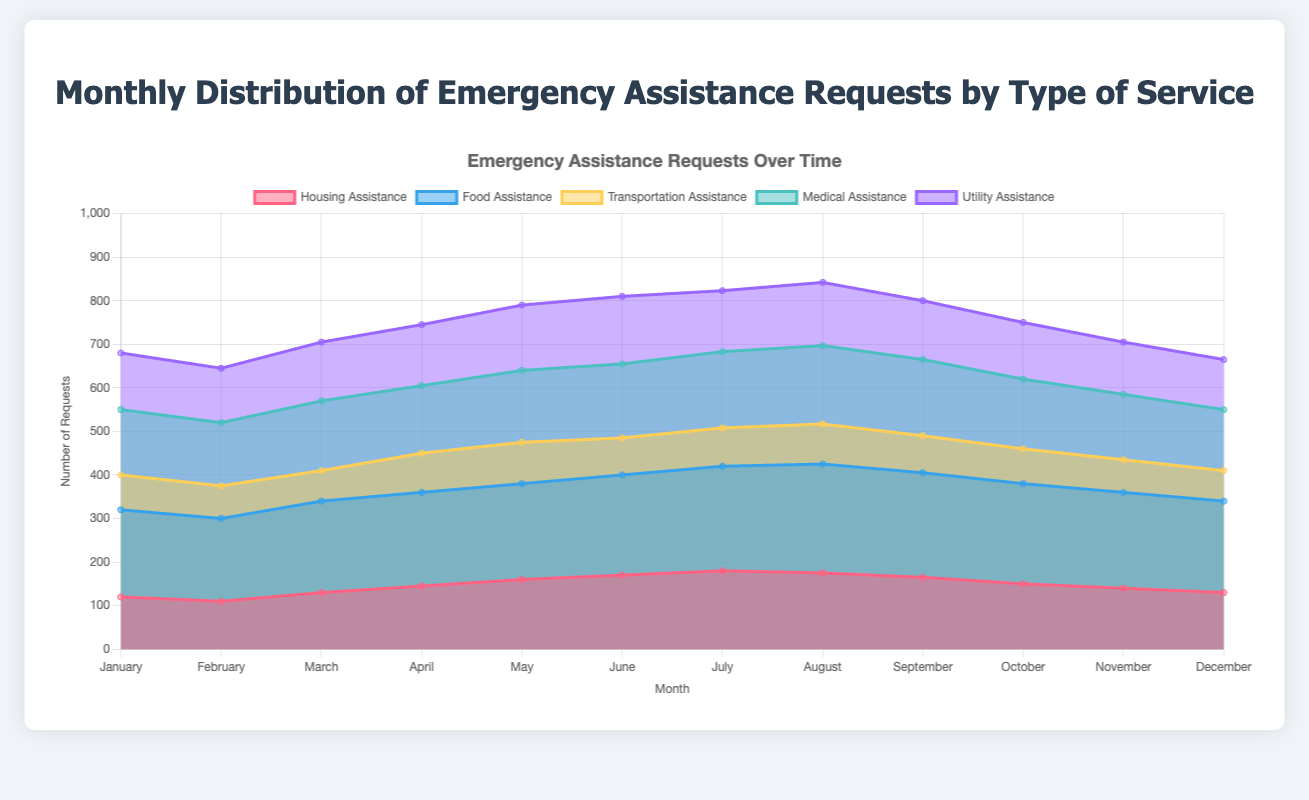What is the title of the chart? The title is typically found at the top of the figure, offering a summary of the visualization. This chart's title is "Monthly Distribution of Emergency Assistance Requests by Type of Service".
Answer: Monthly Distribution of Emergency Assistance Requests by Type of Service Which type of assistance had the highest number of requests in January? By inspecting the data for January, the requests are represented with distinctive colors. The tallest area for January indicates the largest number of requests which is for "Food Assistance" with 200 requests.
Answer: Food Assistance How many total requests were made for Medical Assistance in the first quarter of the year (January to March)? Sum up the values for Medical Assistance in January, February, and March: 150 + 145 + 160 = 455.
Answer: 455 In which month did Transportation Assistance have the highest number of requests? By tracing the series for Transportation Assistance through the months, July stands out as the month with the highest value at 95.
Answer: July Compare the total requests for Housing Assistance and Utility Assistance in December. Which one had more requests? The values in December for Housing Assistance and Utility Assistance are 130 and 115, respectively. 130 is greater than 115, so Housing Assistance had more requests.
Answer: Housing Assistance Which month saw the peak number of requests for Food Assistance? Reviewing the data for Food Assistance over the months, August has the highest value at 250.
Answer: August Calculate the average number of requests for Transportation Assistance from June to August. The values from June to August for Transportation Assistance are 85, 88, and 92. Add them up and divide by 3: (85 + 88 + 92) / 3 = 88.33.
Answer: 88.33 Identify any months where the number of requests for Utility Assistance is lower than the previous month. Evaluate the Utility Assistance values sequentially: February (125 < 130), August (145 < 155), September (135 < 145), November (120 < 130), and December (115 < 120) show declines from the preceding month.
Answer: February, August, September, November, December What trend can you observe in the Medical Assistance requests over the year? Tracking the line for Medical Assistance, it rises steadily from January to August, peaking at 180, before starting to decline towards December at 140.
Answer: Rises until August, then declines Which type of service had the most volatile (largest fluctuation in values) pattern throughout the year? Volatility is seen by the range of the values. Food Assistance fluctuates heavily from 190 to 250, showing a significant change within months compared to other services.
Answer: Food Assistance 